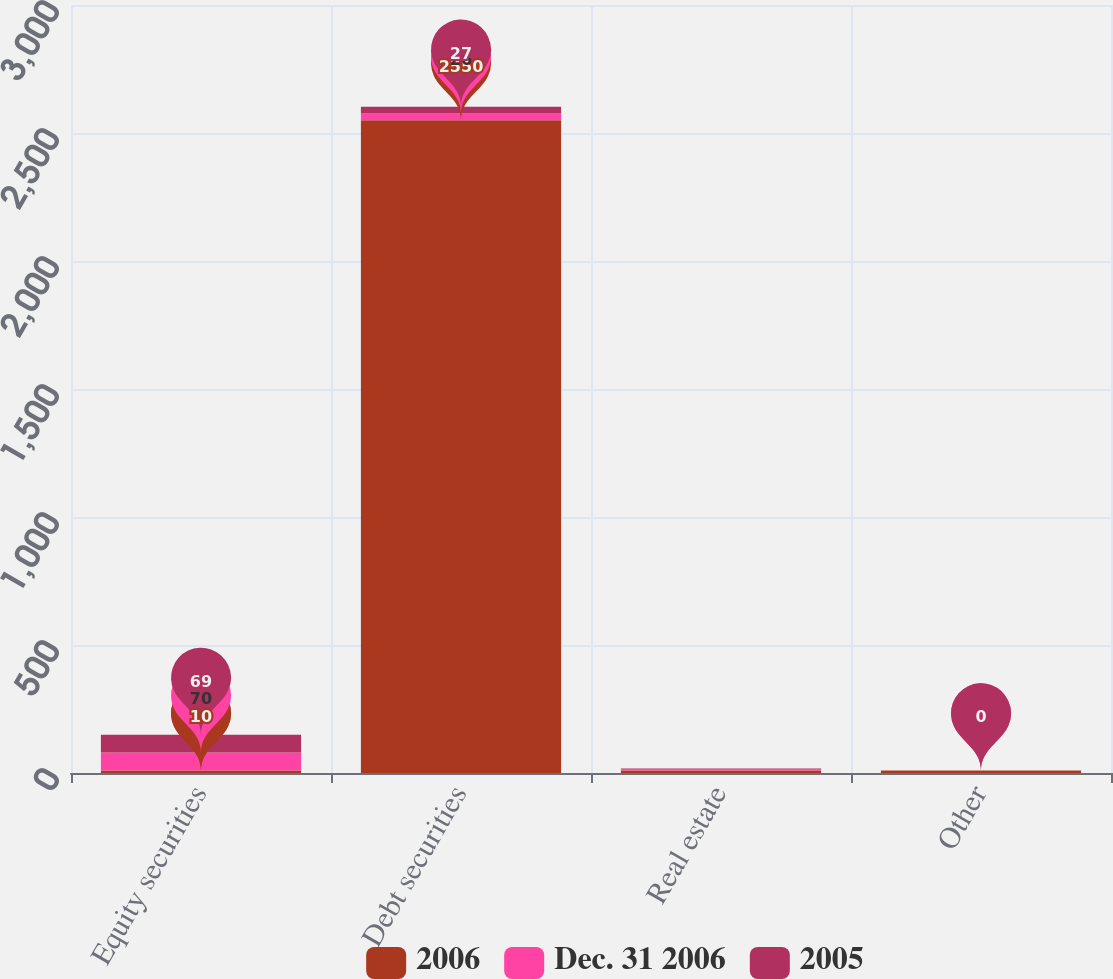Convert chart. <chart><loc_0><loc_0><loc_500><loc_500><stacked_bar_chart><ecel><fcel>Equity securities<fcel>Debt securities<fcel>Real estate<fcel>Other<nl><fcel>2006<fcel>10<fcel>2550<fcel>10<fcel>10<nl><fcel>Dec. 31 2006<fcel>70<fcel>26<fcel>4<fcel>0<nl><fcel>2005<fcel>69<fcel>27<fcel>4<fcel>0<nl></chart> 